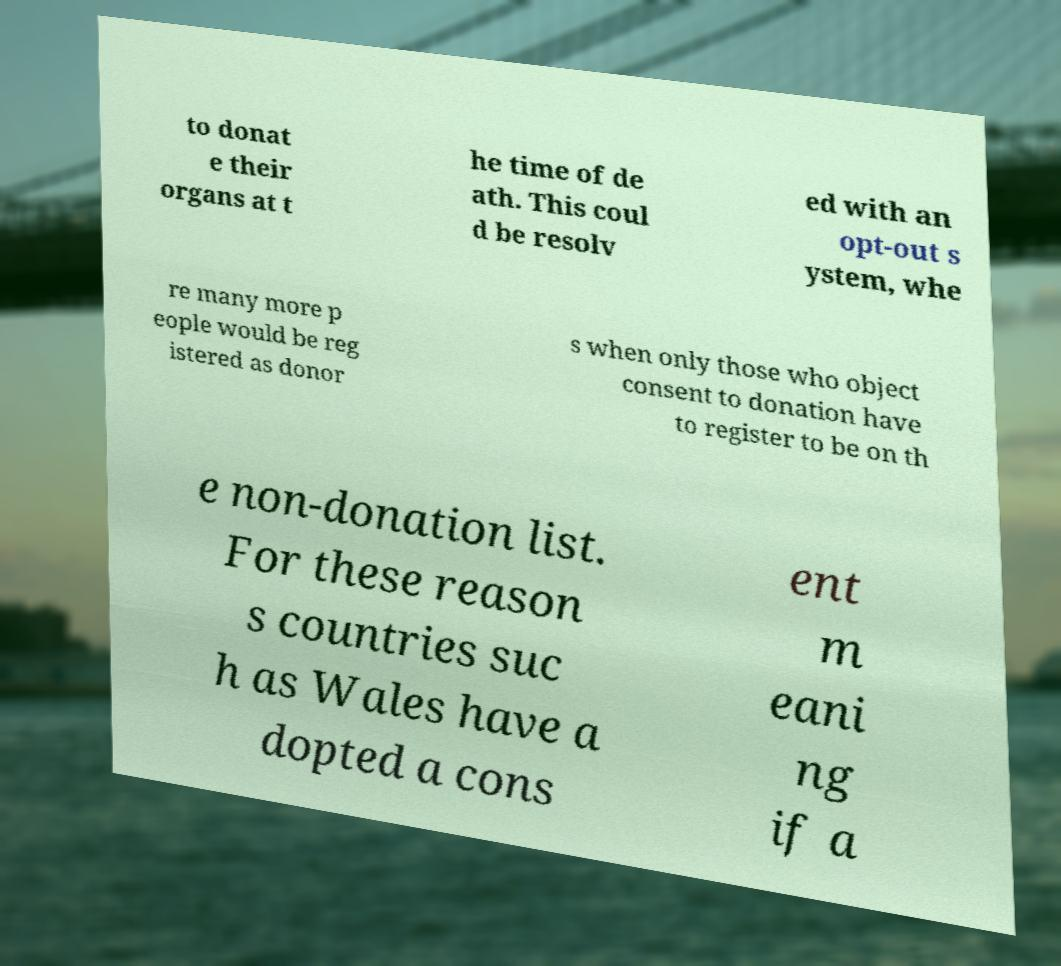Can you accurately transcribe the text from the provided image for me? to donat e their organs at t he time of de ath. This coul d be resolv ed with an opt-out s ystem, whe re many more p eople would be reg istered as donor s when only those who object consent to donation have to register to be on th e non-donation list. For these reason s countries suc h as Wales have a dopted a cons ent m eani ng if a 